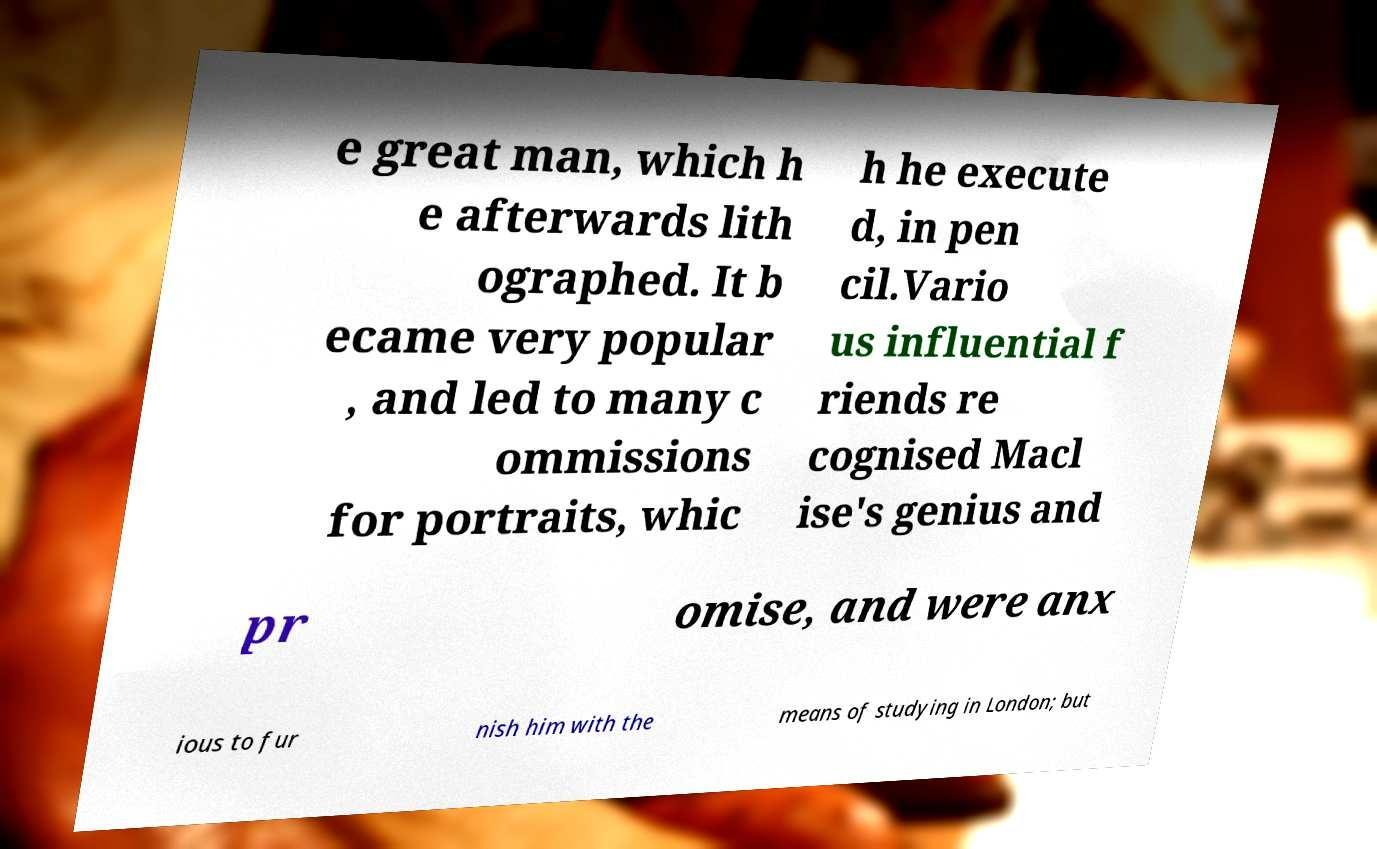Can you accurately transcribe the text from the provided image for me? e great man, which h e afterwards lith ographed. It b ecame very popular , and led to many c ommissions for portraits, whic h he execute d, in pen cil.Vario us influential f riends re cognised Macl ise's genius and pr omise, and were anx ious to fur nish him with the means of studying in London; but 